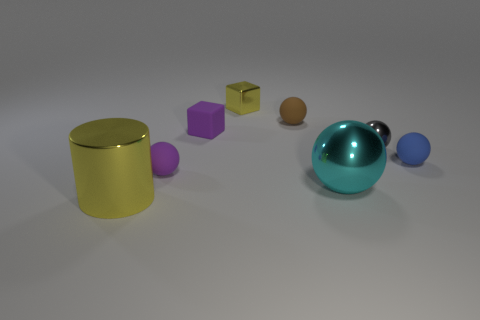Subtract all blue balls. How many balls are left? 4 Subtract all tiny purple rubber spheres. How many spheres are left? 4 Subtract all red spheres. Subtract all purple cylinders. How many spheres are left? 5 Add 1 tiny purple rubber spheres. How many objects exist? 9 Subtract all spheres. How many objects are left? 3 Add 1 blue things. How many blue things are left? 2 Add 6 cyan shiny objects. How many cyan shiny objects exist? 7 Subtract 0 gray blocks. How many objects are left? 8 Subtract all blue metallic blocks. Subtract all cyan balls. How many objects are left? 7 